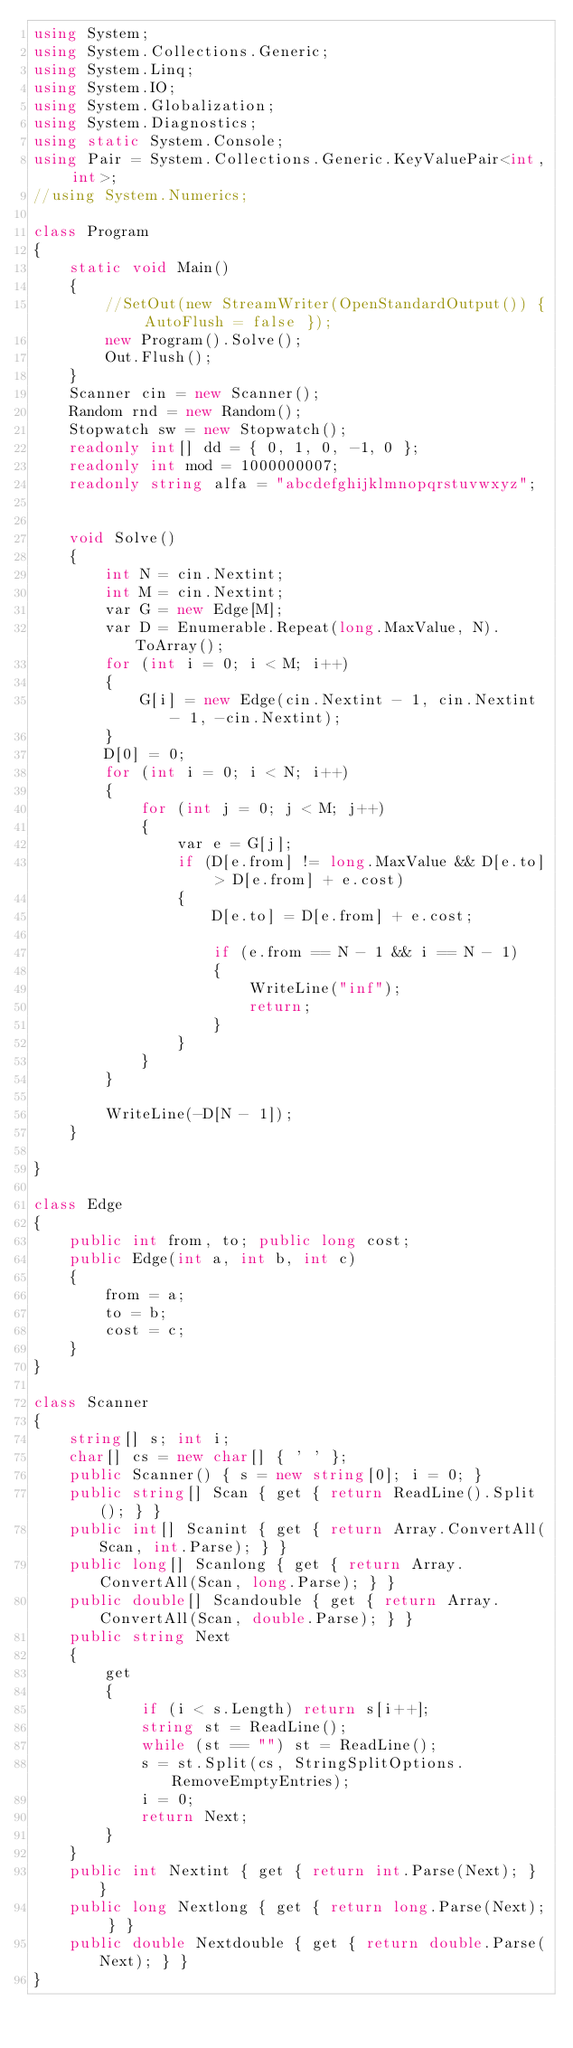<code> <loc_0><loc_0><loc_500><loc_500><_C#_>using System;
using System.Collections.Generic;
using System.Linq;
using System.IO;
using System.Globalization;
using System.Diagnostics;
using static System.Console;
using Pair = System.Collections.Generic.KeyValuePair<int, int>;
//using System.Numerics;
 
class Program
{
    static void Main()
    {
        //SetOut(new StreamWriter(OpenStandardOutput()) { AutoFlush = false });
        new Program().Solve();
        Out.Flush();
    }
    Scanner cin = new Scanner();
    Random rnd = new Random();
    Stopwatch sw = new Stopwatch();
    readonly int[] dd = { 0, 1, 0, -1, 0 };
    readonly int mod = 1000000007;
    readonly string alfa = "abcdefghijklmnopqrstuvwxyz";
 
    
    void Solve()
    {
        int N = cin.Nextint;
        int M = cin.Nextint;
        var G = new Edge[M];
        var D = Enumerable.Repeat(long.MaxValue, N).ToArray();
        for (int i = 0; i < M; i++)
        {
            G[i] = new Edge(cin.Nextint - 1, cin.Nextint - 1, -cin.Nextint);
        }
        D[0] = 0;
        for (int i = 0; i < N; i++)
        {
            for (int j = 0; j < M; j++)
            {
                var e = G[j];
                if (D[e.from] != long.MaxValue && D[e.to] > D[e.from] + e.cost)
                {
                    D[e.to] = D[e.from] + e.cost;
 
                    if (e.from == N - 1 && i == N - 1)
                    {
                        WriteLine("inf");
                        return;
                    }
                }
            }
        }
        
        WriteLine(-D[N - 1]);
    }
 
}
 
class Edge
{
    public int from, to; public long cost;
    public Edge(int a, int b, int c)
    {
        from = a;
        to = b;
        cost = c;
    }
}
 
class Scanner
{
    string[] s; int i;
    char[] cs = new char[] { ' ' };
    public Scanner() { s = new string[0]; i = 0; }
    public string[] Scan { get { return ReadLine().Split(); } }
    public int[] Scanint { get { return Array.ConvertAll(Scan, int.Parse); } }
    public long[] Scanlong { get { return Array.ConvertAll(Scan, long.Parse); } }
    public double[] Scandouble { get { return Array.ConvertAll(Scan, double.Parse); } }
    public string Next
    {
        get
        {
            if (i < s.Length) return s[i++];
            string st = ReadLine();
            while (st == "") st = ReadLine();
            s = st.Split(cs, StringSplitOptions.RemoveEmptyEntries);
            i = 0;
            return Next;
        }
    }
    public int Nextint { get { return int.Parse(Next); } }
    public long Nextlong { get { return long.Parse(Next); } }
    public double Nextdouble { get { return double.Parse(Next); } }
}</code> 